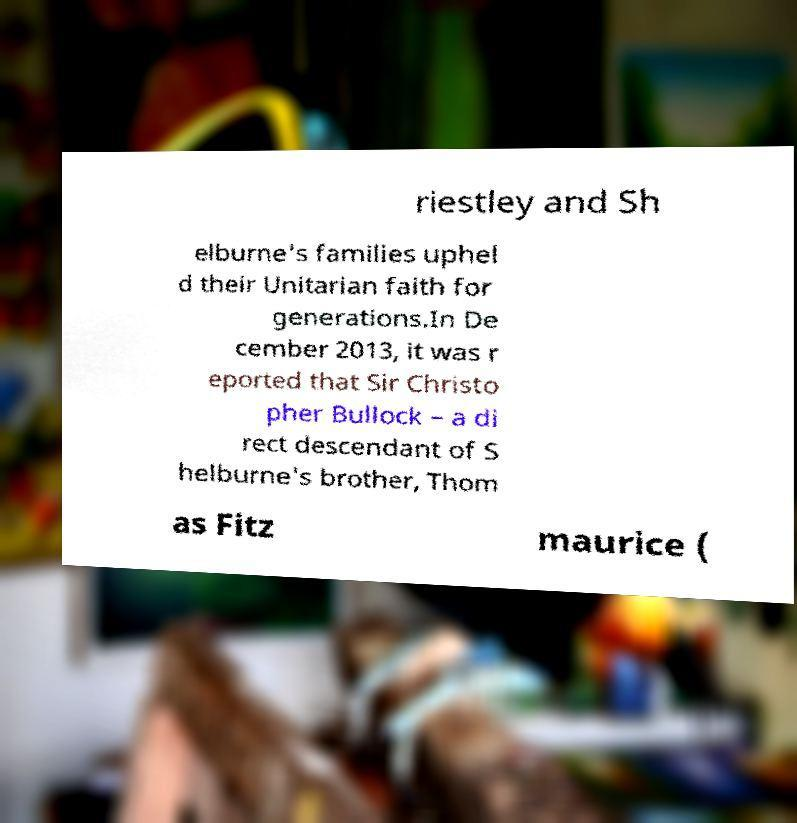Please read and relay the text visible in this image. What does it say? riestley and Sh elburne's families uphel d their Unitarian faith for generations.In De cember 2013, it was r eported that Sir Christo pher Bullock – a di rect descendant of S helburne's brother, Thom as Fitz maurice ( 